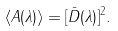<formula> <loc_0><loc_0><loc_500><loc_500>\langle A ( \lambda ) \rangle = [ \bar { D } ( \lambda ) ] ^ { 2 } .</formula> 